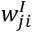<formula> <loc_0><loc_0><loc_500><loc_500>w _ { j i } ^ { I }</formula> 